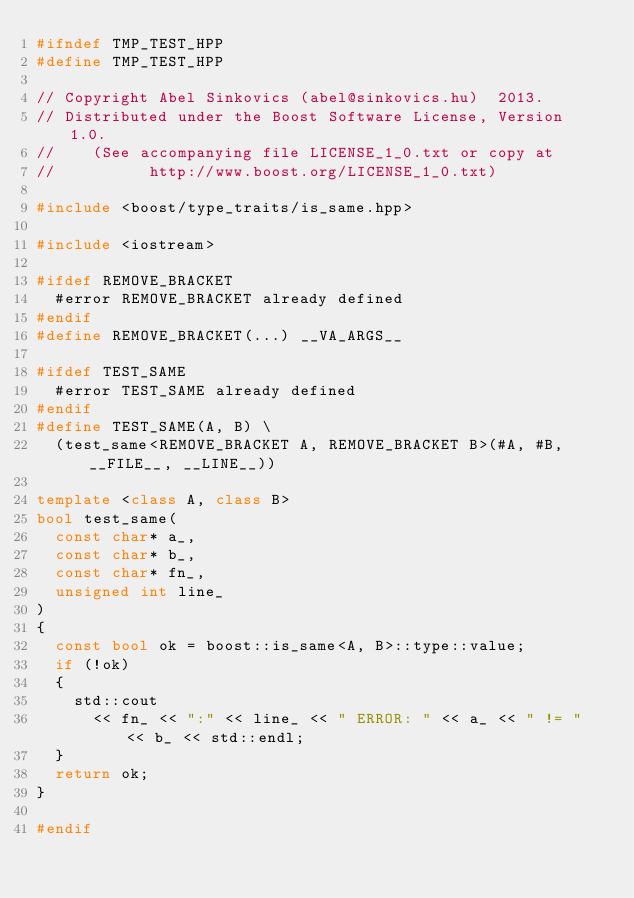Convert code to text. <code><loc_0><loc_0><loc_500><loc_500><_C++_>#ifndef TMP_TEST_HPP
#define TMP_TEST_HPP

// Copyright Abel Sinkovics (abel@sinkovics.hu)  2013.
// Distributed under the Boost Software License, Version 1.0.
//    (See accompanying file LICENSE_1_0.txt or copy at
//          http://www.boost.org/LICENSE_1_0.txt)

#include <boost/type_traits/is_same.hpp>

#include <iostream>

#ifdef REMOVE_BRACKET
  #error REMOVE_BRACKET already defined
#endif
#define REMOVE_BRACKET(...) __VA_ARGS__

#ifdef TEST_SAME
  #error TEST_SAME already defined
#endif
#define TEST_SAME(A, B) \
  (test_same<REMOVE_BRACKET A, REMOVE_BRACKET B>(#A, #B, __FILE__, __LINE__))

template <class A, class B>
bool test_same(
  const char* a_,
  const char* b_,
  const char* fn_,
  unsigned int line_
)
{
  const bool ok = boost::is_same<A, B>::type::value;
  if (!ok)
  {
    std::cout
      << fn_ << ":" << line_ << " ERROR: " << a_ << " != " << b_ << std::endl;
  }
  return ok;
}

#endif

</code> 